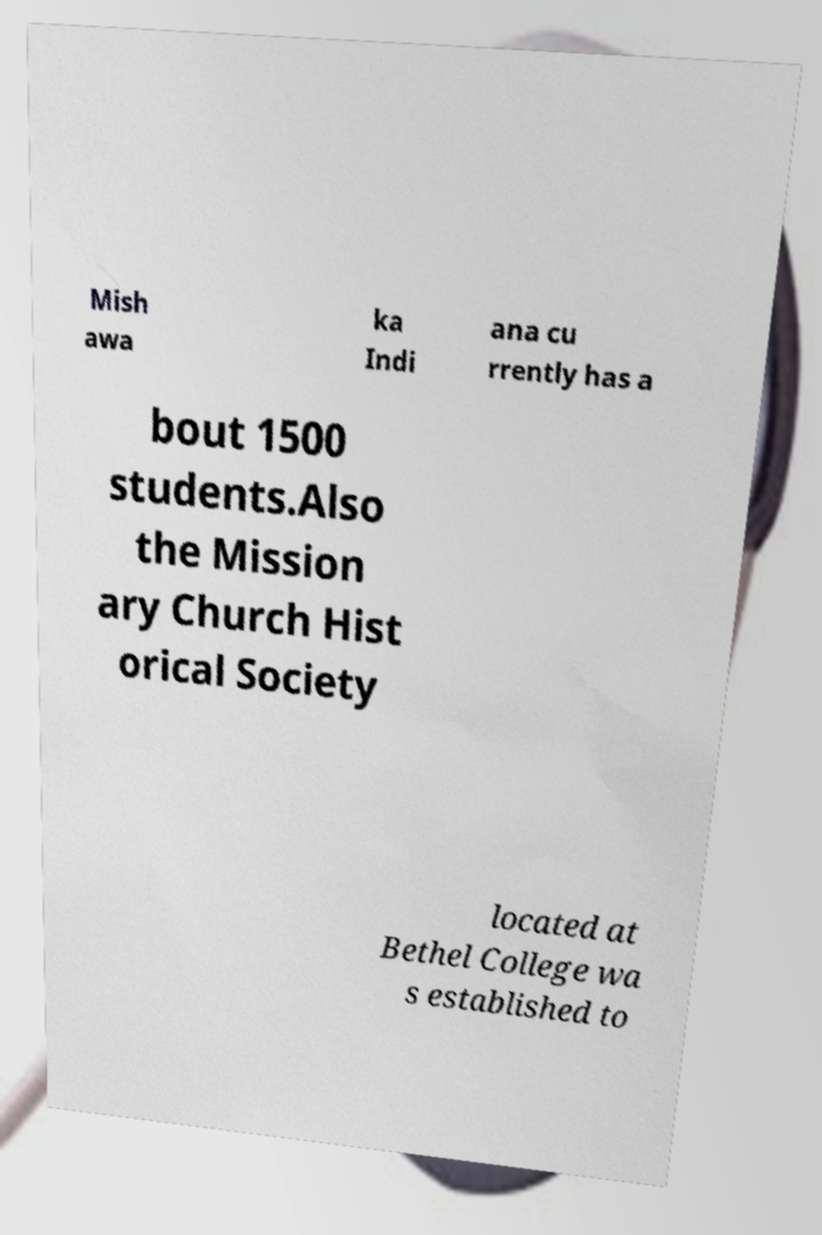Please identify and transcribe the text found in this image. Mish awa ka Indi ana cu rrently has a bout 1500 students.Also the Mission ary Church Hist orical Society located at Bethel College wa s established to 